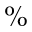Convert formula to latex. <formula><loc_0><loc_0><loc_500><loc_500>\%</formula> 